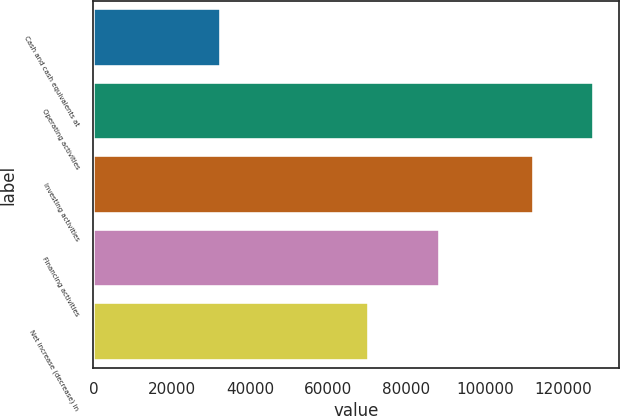Convert chart. <chart><loc_0><loc_0><loc_500><loc_500><bar_chart><fcel>Cash and cash equivalents at<fcel>Operating activities<fcel>Investing activities<fcel>Financing activities<fcel>Net increase (decrease) in<nl><fcel>32741<fcel>127797<fcel>112574<fcel>88624<fcel>70327<nl></chart> 